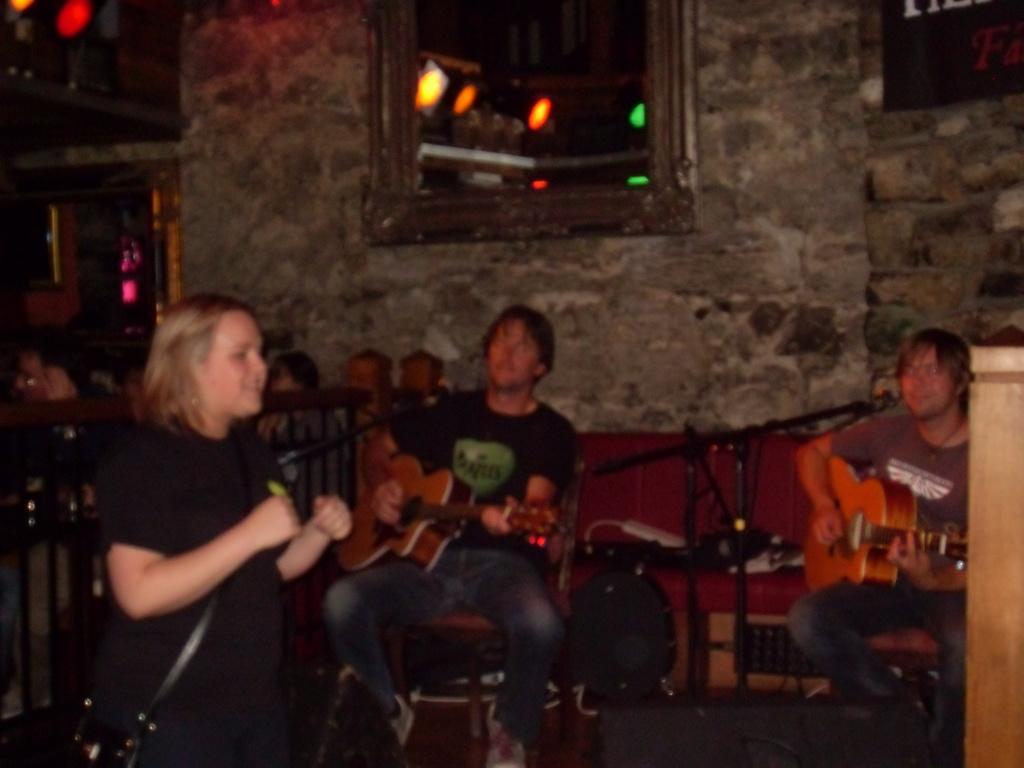Could you give a brief overview of what you see in this image? This is an image clicked in the dark. On the left side there is a woman wearing a bag and it seems like she is dancing. On the right side there is a wooden object. In the background there are two men sitting on the chairs and playing the guitars. In front of these men there are two mike stands. In the background there are few people and chairs. At the top of the image there is a window to the wall and also I can see few lights. 